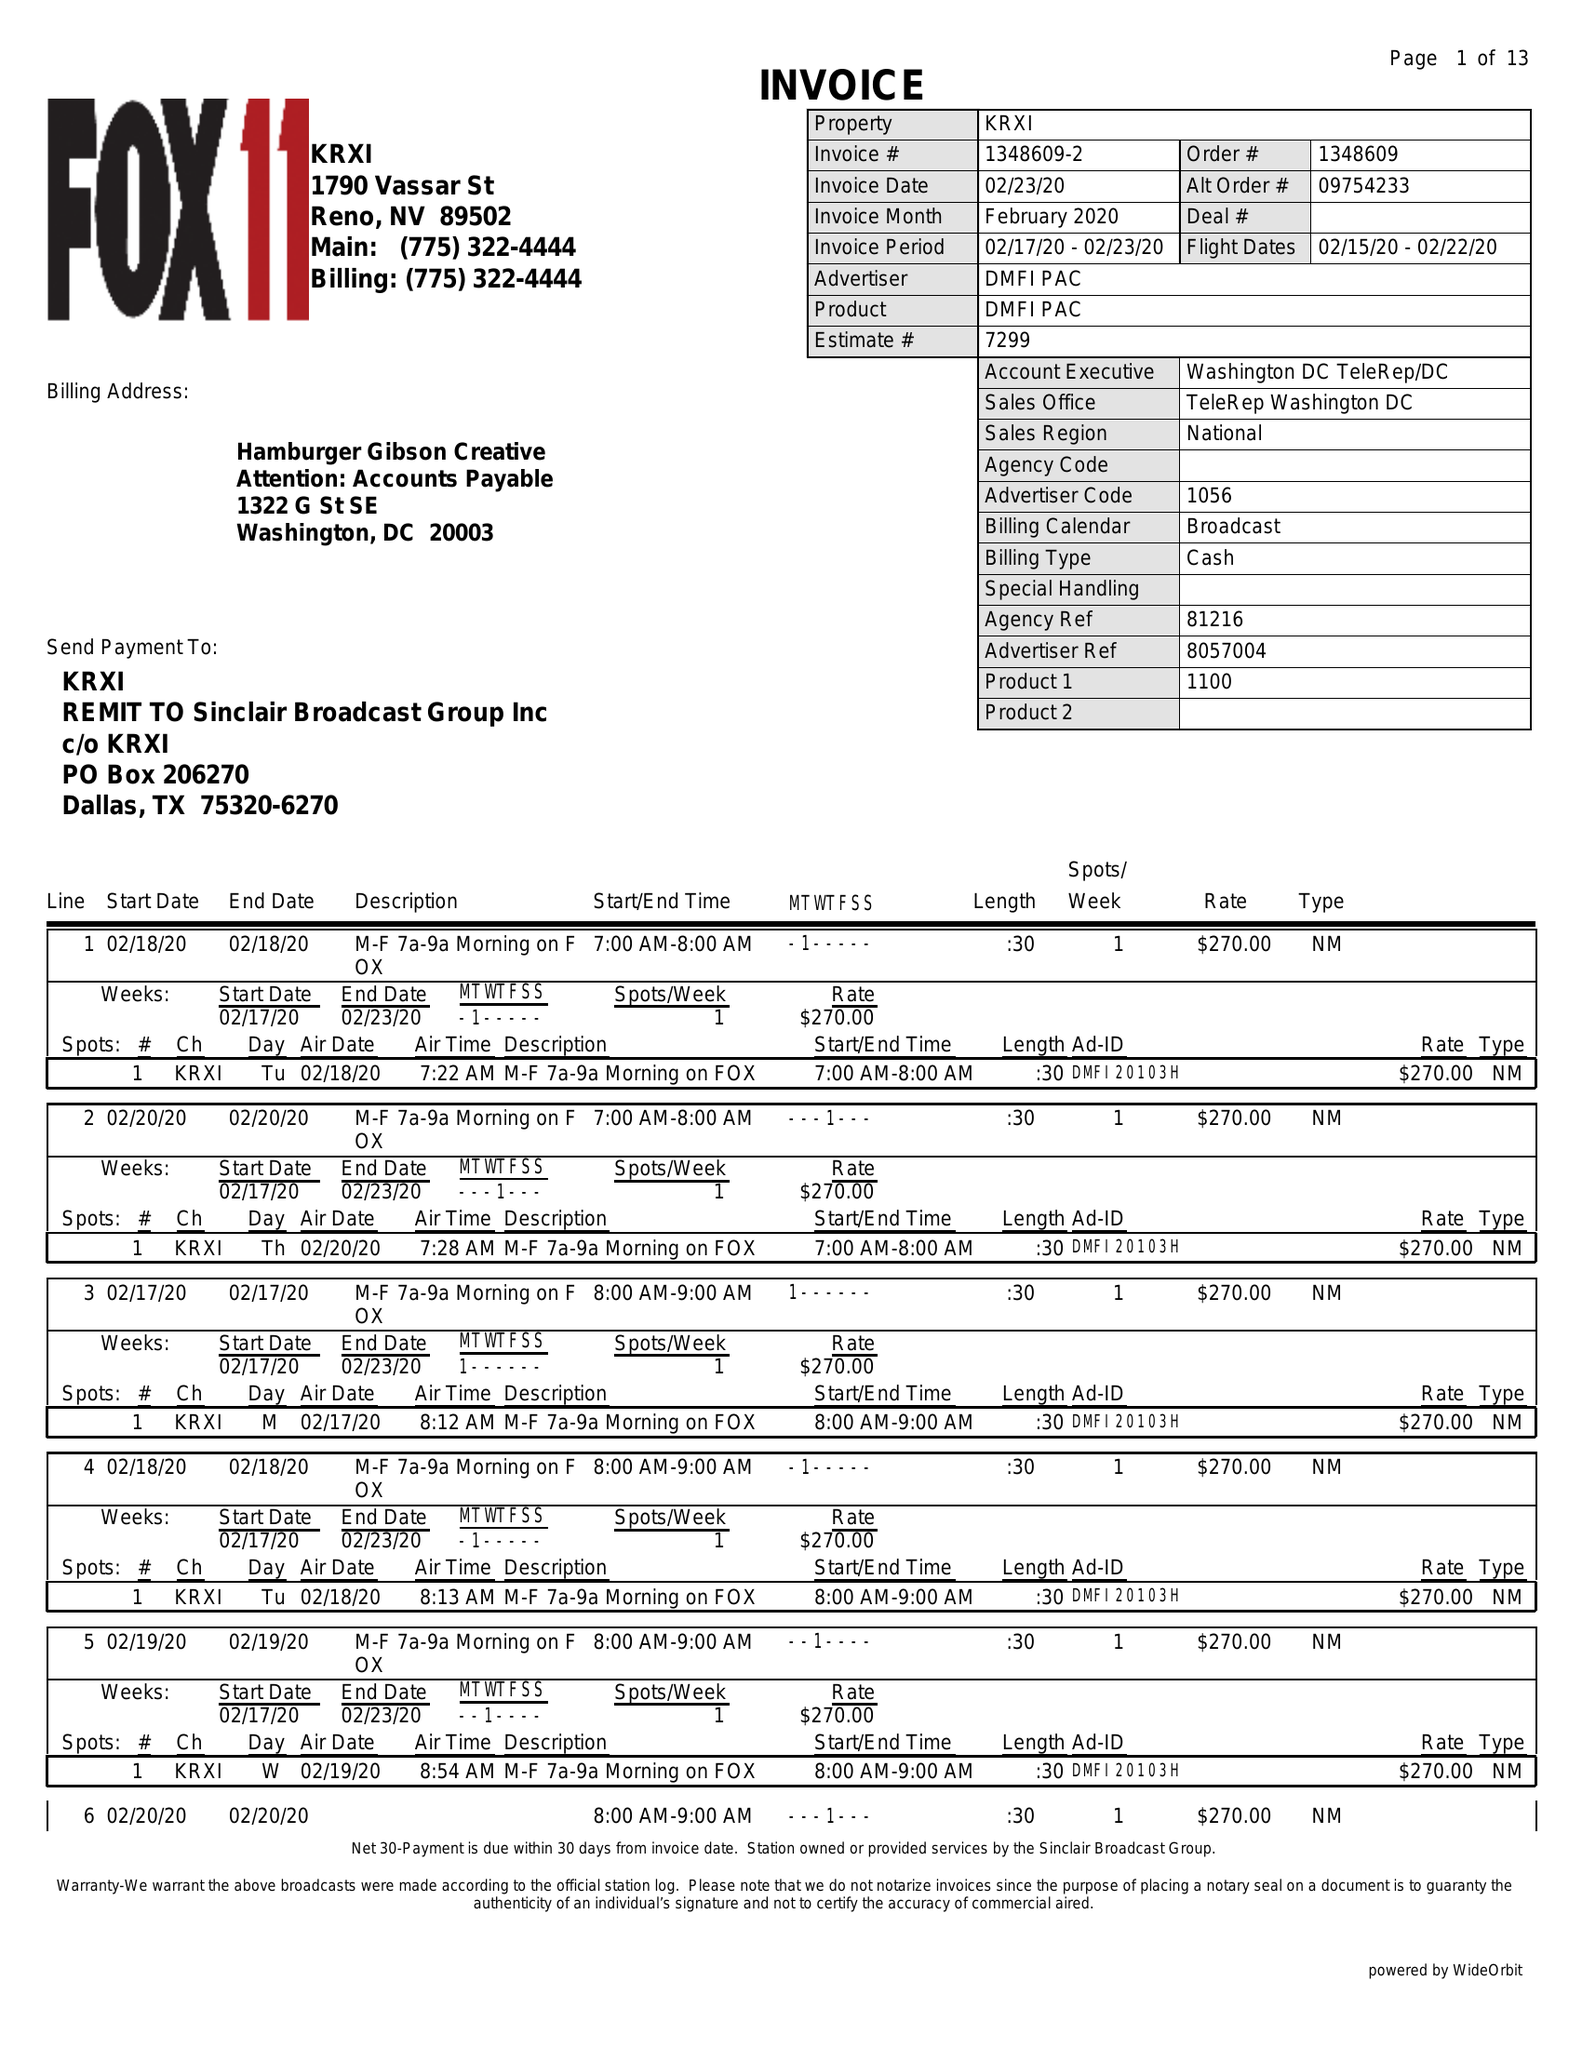What is the value for the flight_from?
Answer the question using a single word or phrase. 02/15/20 